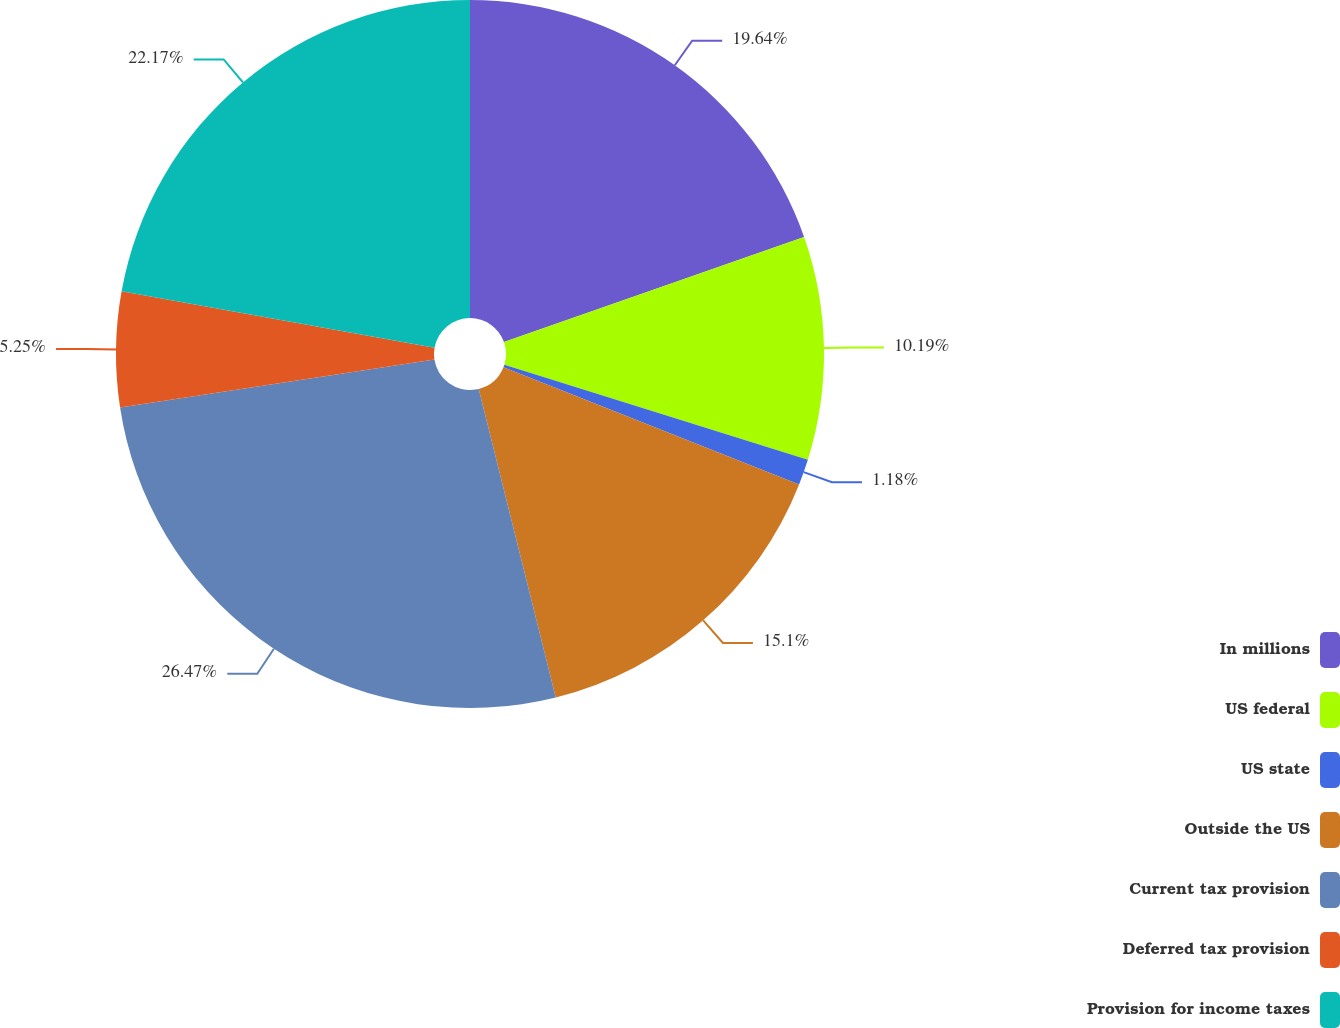<chart> <loc_0><loc_0><loc_500><loc_500><pie_chart><fcel>In millions<fcel>US federal<fcel>US state<fcel>Outside the US<fcel>Current tax provision<fcel>Deferred tax provision<fcel>Provision for income taxes<nl><fcel>19.64%<fcel>10.19%<fcel>1.18%<fcel>15.1%<fcel>26.48%<fcel>5.25%<fcel>22.17%<nl></chart> 